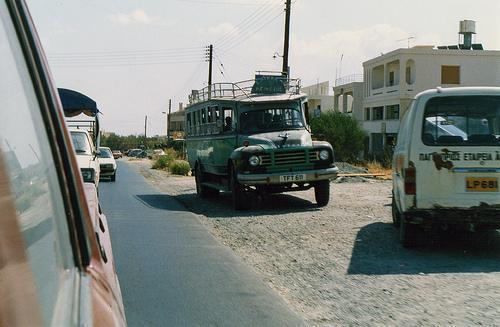How many vehicles are on the right?
Give a very brief answer. 2. 